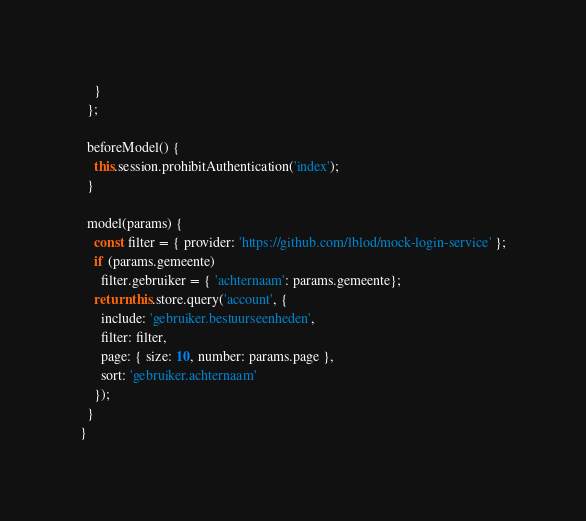<code> <loc_0><loc_0><loc_500><loc_500><_JavaScript_>    }
  };

  beforeModel() {
    this.session.prohibitAuthentication('index');
  }

  model(params) {
    const filter = { provider: 'https://github.com/lblod/mock-login-service' };
    if (params.gemeente)
      filter.gebruiker = { 'achternaam': params.gemeente};
    return this.store.query('account', {
      include: 'gebruiker.bestuurseenheden',
      filter: filter,
      page: { size: 10, number: params.page },
      sort: 'gebruiker.achternaam'
    });
  }
}
</code> 